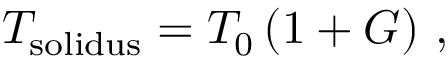Convert formula to latex. <formula><loc_0><loc_0><loc_500><loc_500>T _ { s o l i d u s } = T _ { 0 } \left ( 1 + G \right ) \, ,</formula> 